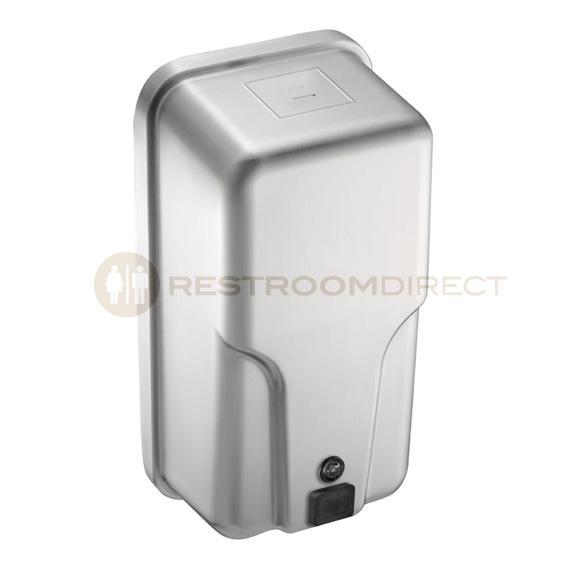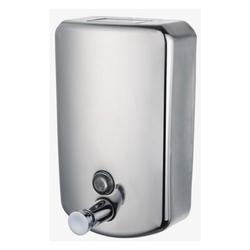The first image is the image on the left, the second image is the image on the right. For the images displayed, is the sentence "The dispenser on the right is a cylinder with a narrow nozzle." factually correct? Answer yes or no. No. 